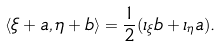Convert formula to latex. <formula><loc_0><loc_0><loc_500><loc_500>\langle \xi + a , \eta + b \rangle = \frac { 1 } { 2 } ( \iota _ { \xi } b + \iota _ { \eta } a ) .</formula> 